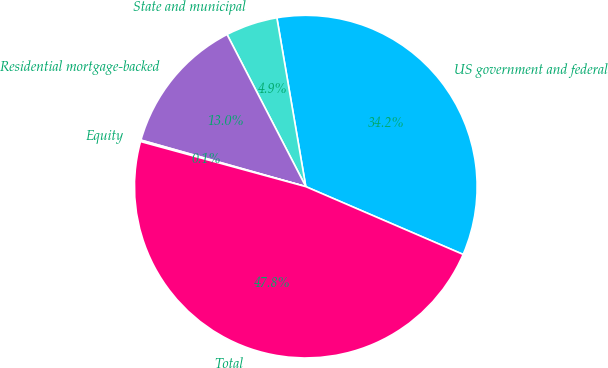Convert chart to OTSL. <chart><loc_0><loc_0><loc_500><loc_500><pie_chart><fcel>US government and federal<fcel>State and municipal<fcel>Residential mortgage-backed<fcel>Equity<fcel>Total<nl><fcel>34.18%<fcel>4.9%<fcel>13.02%<fcel>0.14%<fcel>47.77%<nl></chart> 